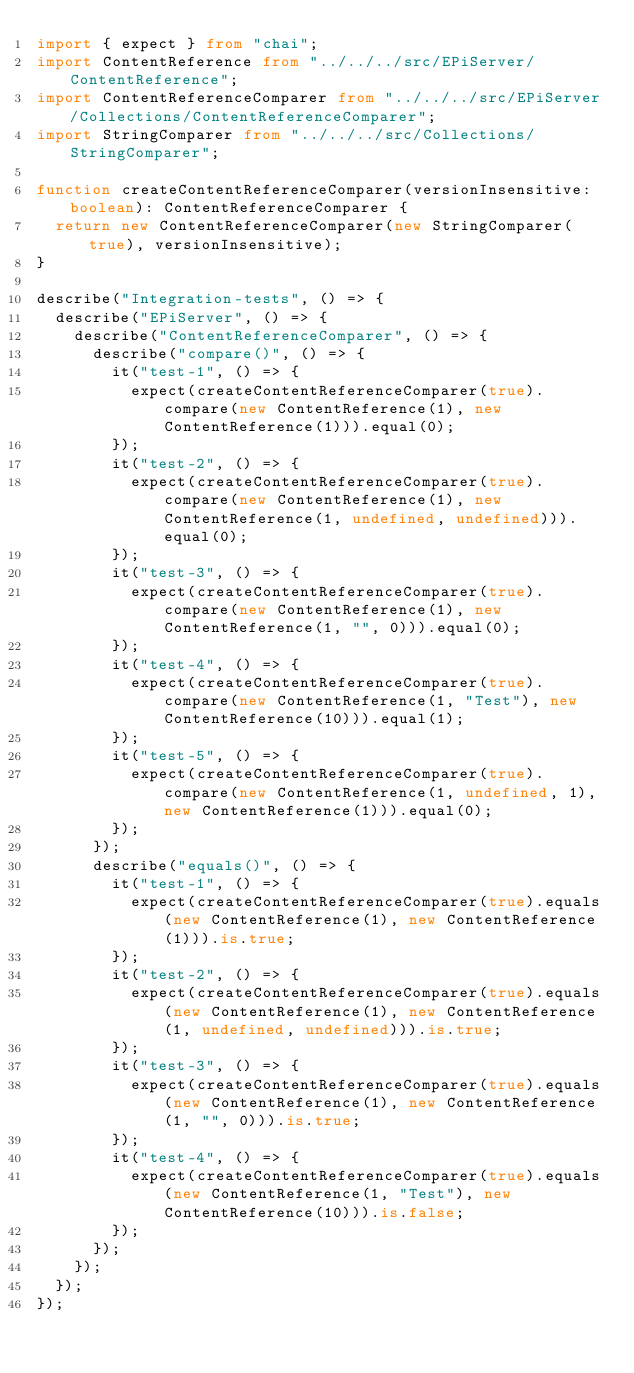<code> <loc_0><loc_0><loc_500><loc_500><_TypeScript_>import { expect } from "chai";
import ContentReference from "../../../src/EPiServer/ContentReference";
import ContentReferenceComparer from "../../../src/EPiServer/Collections/ContentReferenceComparer";
import StringComparer from "../../../src/Collections/StringComparer";

function createContentReferenceComparer(versionInsensitive: boolean): ContentReferenceComparer {
	return new ContentReferenceComparer(new StringComparer(true), versionInsensitive);
}

describe("Integration-tests", () => {
	describe("EPiServer", () => {
		describe("ContentReferenceComparer", () => {
			describe("compare()", () => {
				it("test-1", () => {
					expect(createContentReferenceComparer(true).compare(new ContentReference(1), new ContentReference(1))).equal(0);
				});
				it("test-2", () => {
					expect(createContentReferenceComparer(true).compare(new ContentReference(1), new ContentReference(1, undefined, undefined))).equal(0);
				});
				it("test-3", () => {
					expect(createContentReferenceComparer(true).compare(new ContentReference(1), new ContentReference(1, "", 0))).equal(0);
				});
				it("test-4", () => {
					expect(createContentReferenceComparer(true).compare(new ContentReference(1, "Test"), new ContentReference(10))).equal(1);
				});
				it("test-5", () => {
					expect(createContentReferenceComparer(true).compare(new ContentReference(1, undefined, 1), new ContentReference(1))).equal(0);
				});
			});
			describe("equals()", () => {
				it("test-1", () => {
					expect(createContentReferenceComparer(true).equals(new ContentReference(1), new ContentReference(1))).is.true;
				});
				it("test-2", () => {
					expect(createContentReferenceComparer(true).equals(new ContentReference(1), new ContentReference(1, undefined, undefined))).is.true;
				});
				it("test-3", () => {
					expect(createContentReferenceComparer(true).equals(new ContentReference(1), new ContentReference(1, "", 0))).is.true;
				});
				it("test-4", () => {
					expect(createContentReferenceComparer(true).equals(new ContentReference(1, "Test"), new ContentReference(10))).is.false;
				});
			});
		});
	});
});</code> 